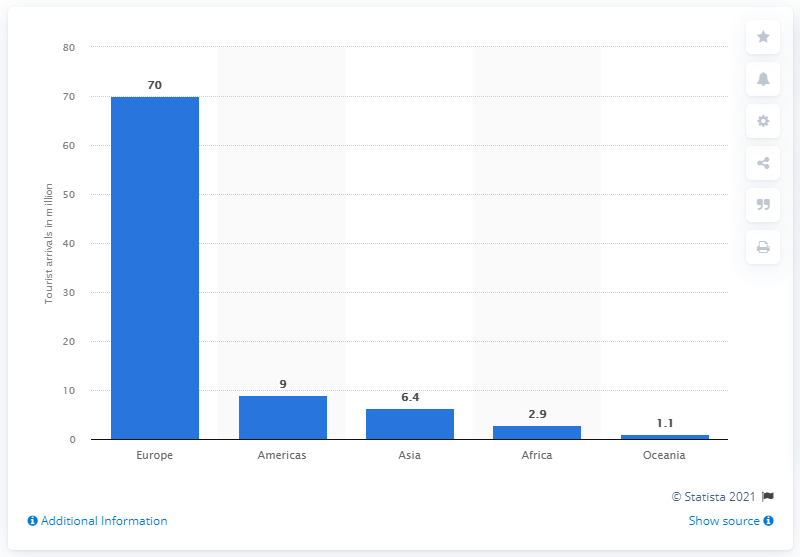Give some essential details in this illustration. In 2018, approximately 9 million Americans traveled to France. In 2018, it is estimated that 70 million Europeans visited France. 